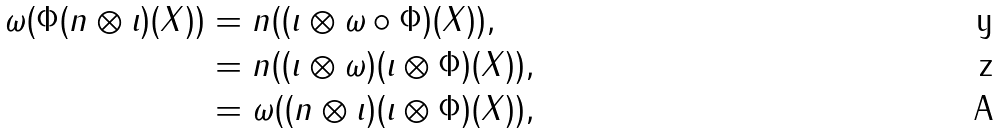<formula> <loc_0><loc_0><loc_500><loc_500>\omega ( \Phi ( n \otimes \iota ) ( X ) ) & = n ( ( \iota \otimes \omega \circ \Phi ) ( X ) ) , \\ & = n ( ( \iota \otimes \omega ) ( \iota \otimes \Phi ) ( X ) ) , \\ & = \omega ( ( n \otimes \iota ) ( \iota \otimes \Phi ) ( X ) ) ,</formula> 